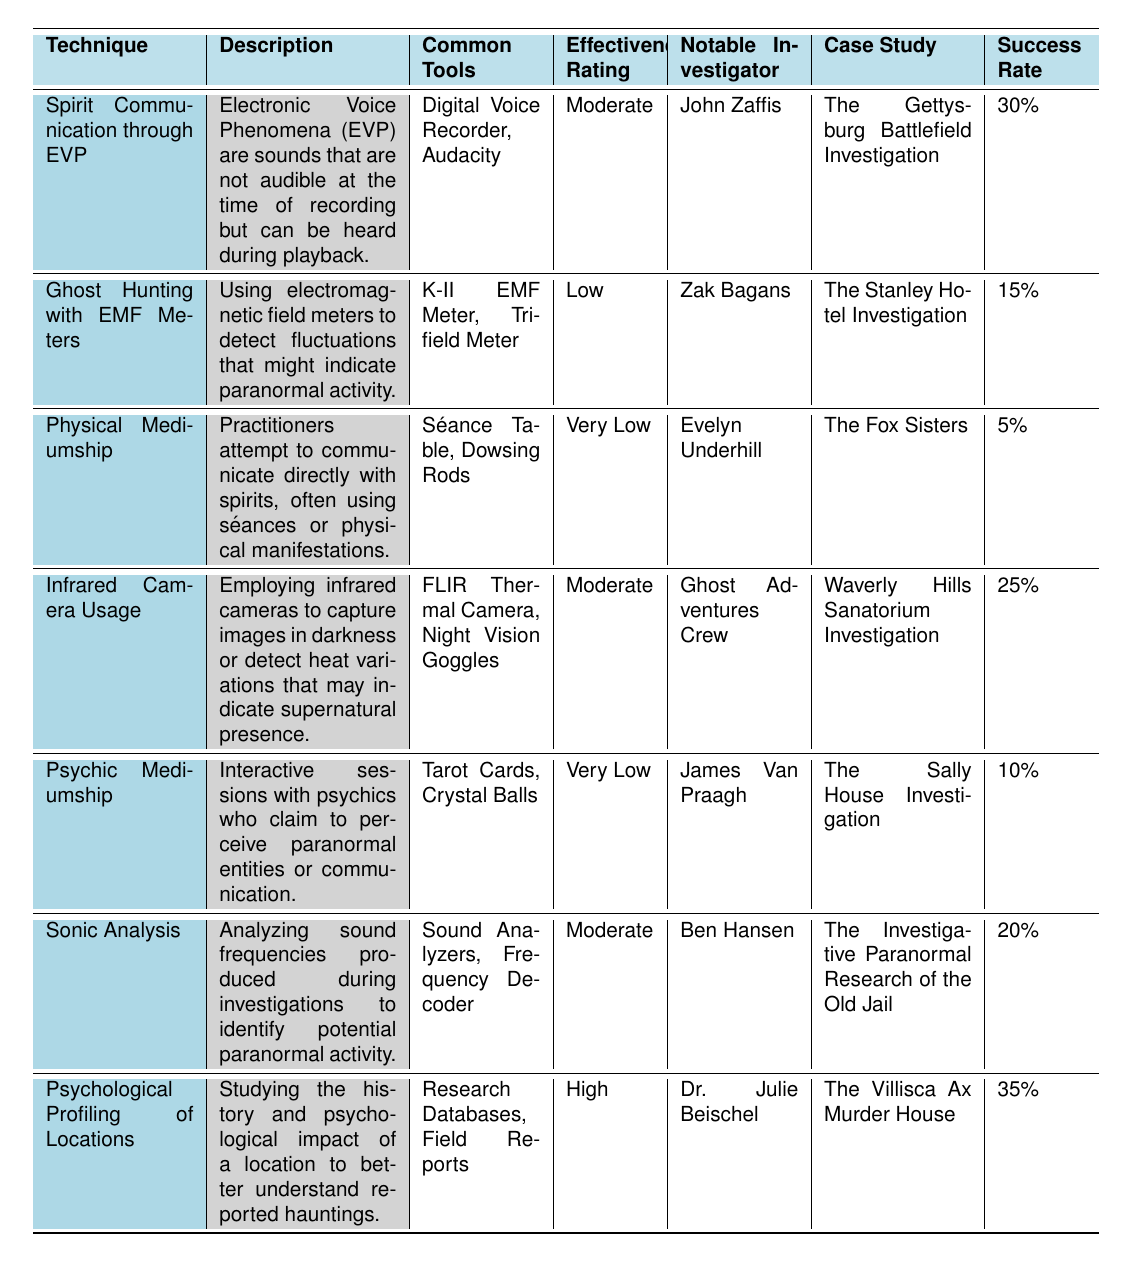What is the effectiveness rating of "Psychological Profiling of Locations"? The effectiveness rating is listed directly in the table under the corresponding technique, which shows this technique has a rating of "High".
Answer: High Who is the notable investigator for "Sonic Analysis"? The table provides the name of the notable investigator associated with the "Sonic Analysis" technique, which is Ben Hansen.
Answer: Ben Hansen What is the success rate for "Ghost Hunting with EMF Meters"? You can find this information in the table under the "Success Rate" column for the "Ghost Hunting with EMF Meters" technique, which is 15%.
Answer: 15% Which technique has the highest success rate? By comparing the success rates listed in the "Success Rate" column, the technique with the highest success rate is "Psychological Profiling of Locations" at 35%.
Answer: Psychological Profiling of Locations How many techniques have a success rate greater than 20%? First, examine the success rates in the table. The techniques with a success rate greater than 20% are "Psychological Profiling of Locations" (35%), "Spirit Communication through EVP" (30%), and "Infrared Camera Usage" (25%). This results in a total of three techniques.
Answer: 3 Is "Psychic Mediumship" rated higher than "Ghost Hunting with EMF Meters"? To compare, check the effectiveness ratings: "Psychic Mediumship" is rated as "Very Low," and "Ghost Hunting with EMF Meters" is rated as "Low." Since "Low" is higher than "Very Low," "Psychic Mediumship" is not rated higher.
Answer: No If you combine the success rates of "Infrared Camera Usage" and "Sonic Analysis," what is the total? The success rates for these two techniques are 25% for "Infrared Camera Usage" and 20% for "Sonic Analysis". Adding them together gives 25% + 20% = 45%.
Answer: 45% What is the common tool used in "Physical Mediumship"? The common tools used for this technique are listed in the table, which includes "Séance Table" and "Dowsing Rods".
Answer: Séance Table, Dowsing Rods Which technique has the lowest success rate and who is the notable investigator for it? Looking at the success rates, "Physical Mediumship" has the lowest at 5%. The notable investigator associated with this technique is Evelyn Underhill.
Answer: Evelyn Underhill What percentage difference in success rate is there between "Psychological Profiling of Locations" and "Physical Mediumship"? The success rate for "Psychological Profiling of Locations" is 35% and for "Physical Mediumship" is 5%. The difference is 35% - 5% = 30%.
Answer: 30% 